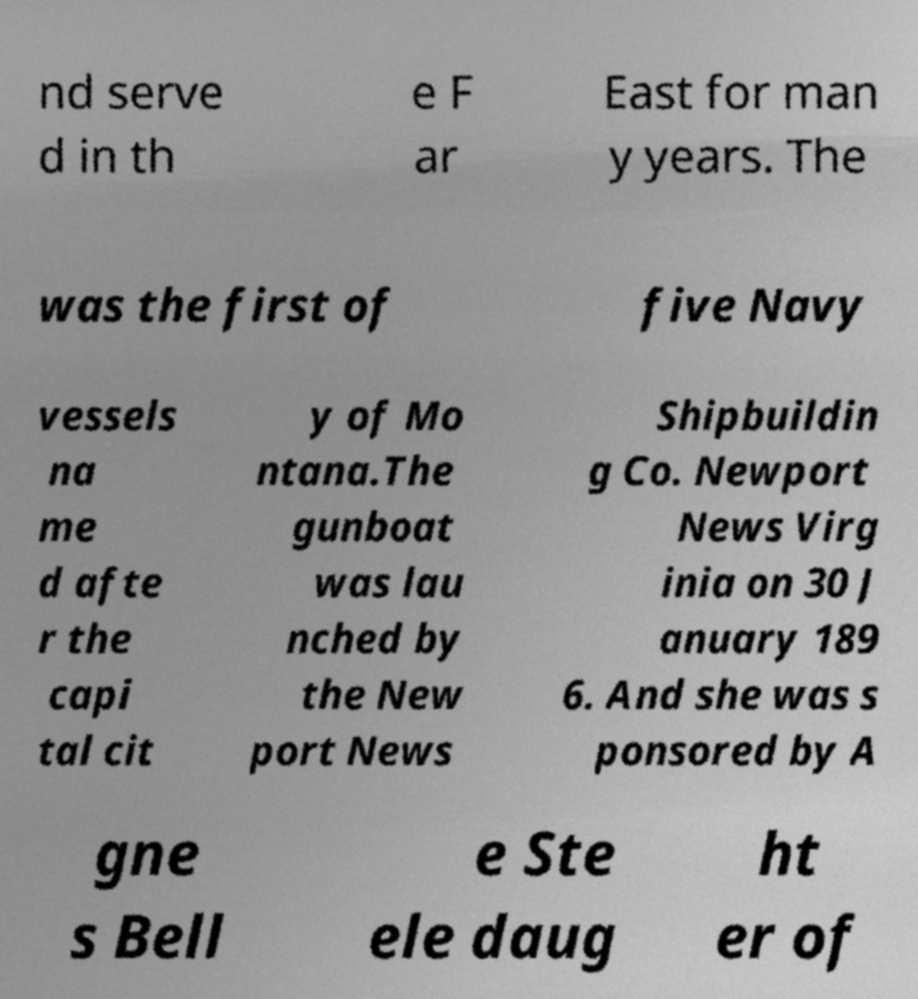For documentation purposes, I need the text within this image transcribed. Could you provide that? nd serve d in th e F ar East for man y years. The was the first of five Navy vessels na me d afte r the capi tal cit y of Mo ntana.The gunboat was lau nched by the New port News Shipbuildin g Co. Newport News Virg inia on 30 J anuary 189 6. And she was s ponsored by A gne s Bell e Ste ele daug ht er of 